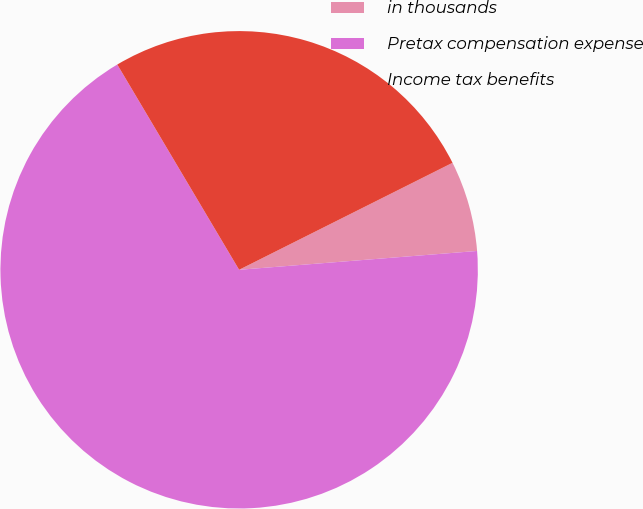Convert chart to OTSL. <chart><loc_0><loc_0><loc_500><loc_500><pie_chart><fcel>in thousands<fcel>Pretax compensation expense<fcel>Income tax benefits<nl><fcel>6.14%<fcel>67.73%<fcel>26.13%<nl></chart> 